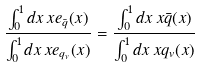<formula> <loc_0><loc_0><loc_500><loc_500>\frac { \int _ { 0 } ^ { 1 } d x \, x e _ { \bar { q } } ( x ) } { \int _ { 0 } ^ { 1 } d x \, x e _ { q _ { v } } ( x ) } = \frac { \int _ { 0 } ^ { 1 } d x \, x \bar { q } ( x ) } { \int _ { 0 } ^ { 1 } d x \, x q _ { v } ( x ) }</formula> 